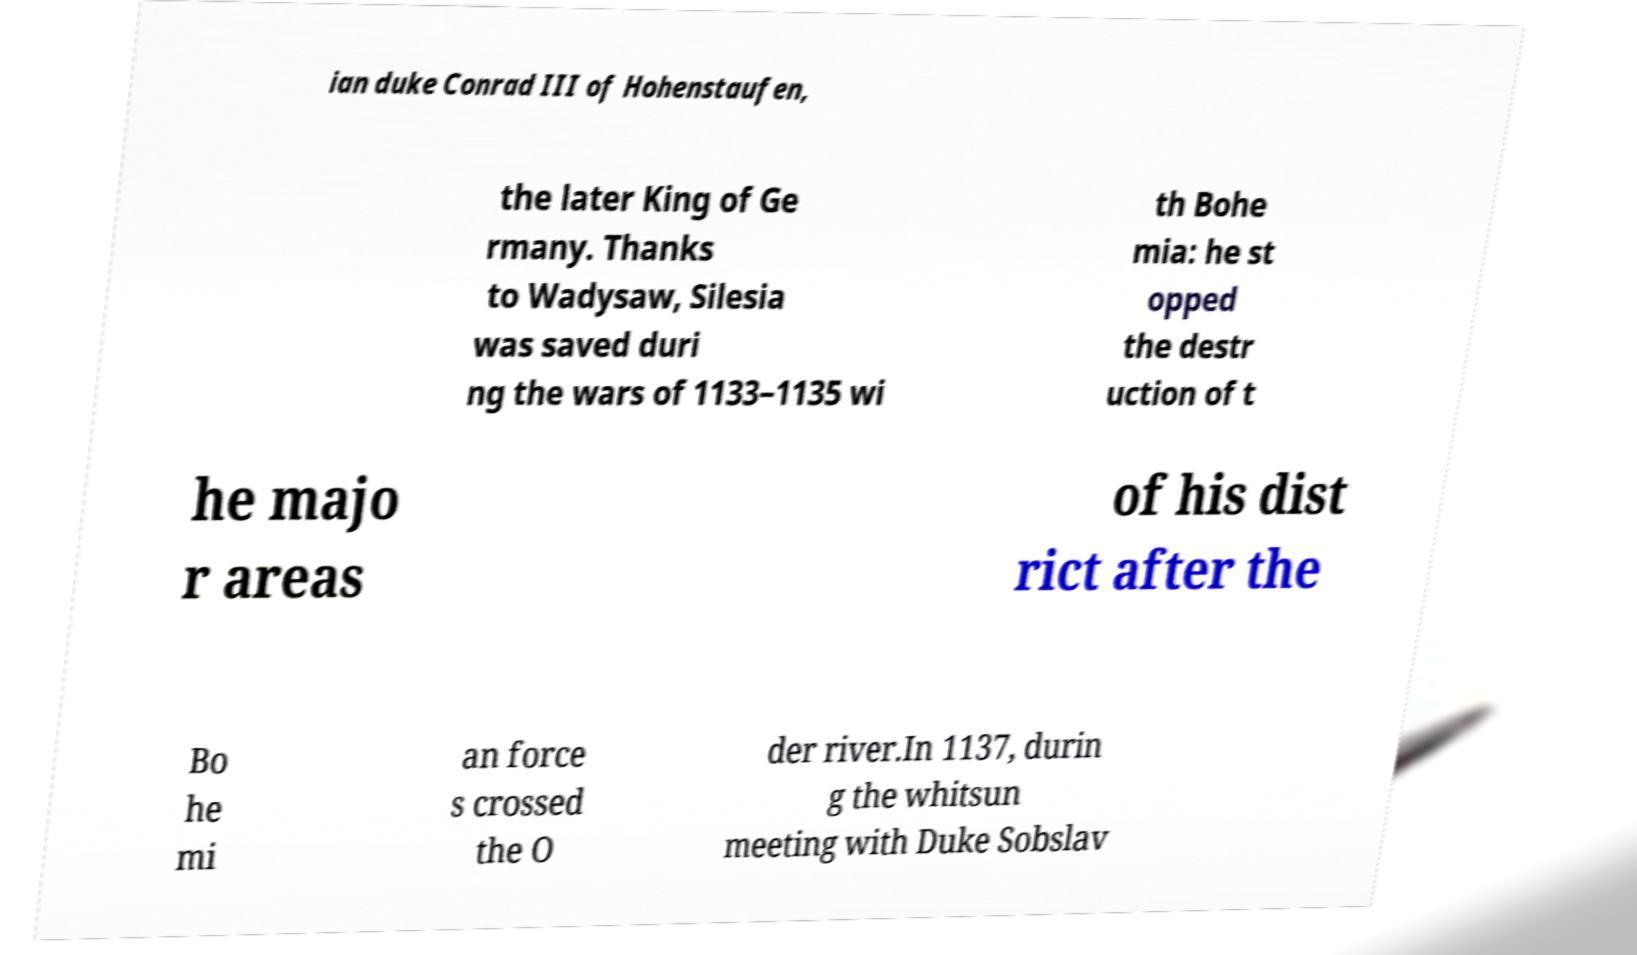What messages or text are displayed in this image? I need them in a readable, typed format. ian duke Conrad III of Hohenstaufen, the later King of Ge rmany. Thanks to Wadysaw, Silesia was saved duri ng the wars of 1133–1135 wi th Bohe mia: he st opped the destr uction of t he majo r areas of his dist rict after the Bo he mi an force s crossed the O der river.In 1137, durin g the whitsun meeting with Duke Sobslav 